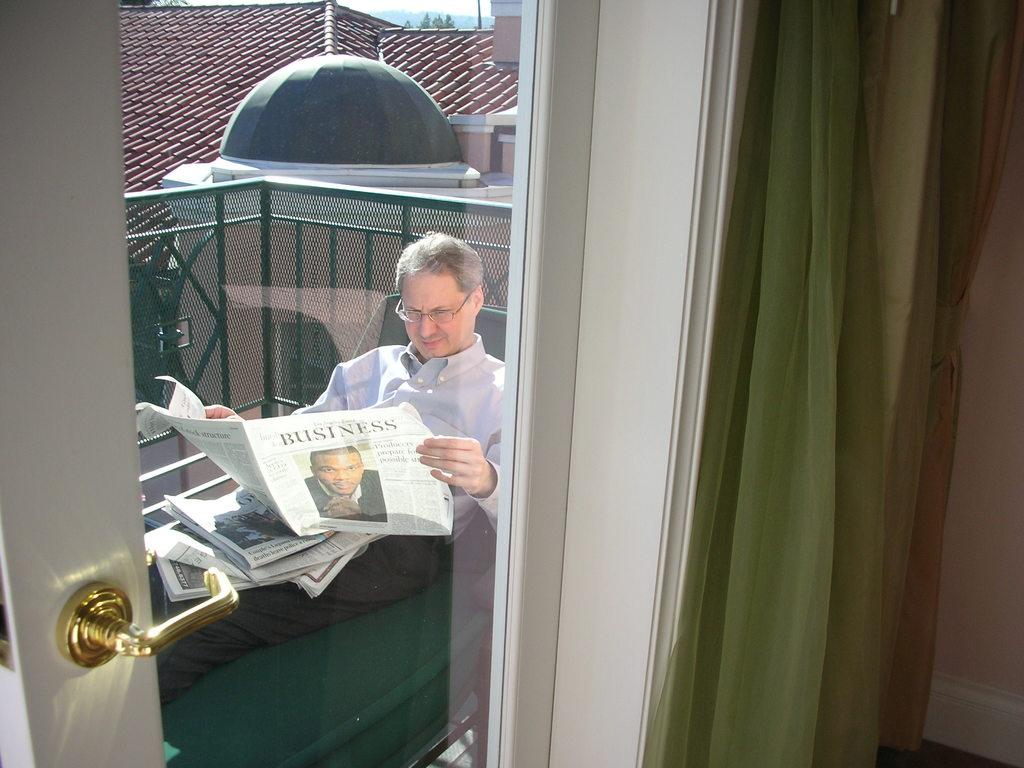What type of structures can be seen in the image? There are houses in the image. What type of window treatment is present in the image? There is a curtain in the image. What type of barrier can be seen in the image? There is a fence in the image. What type of reading material is present in the image? There are newspapers in the image. What type of entrance is present in the image? There is a door in the image. What is the person in the image doing? There is a person sitting in the image. What type of rice is being cooked in the image? There is no rice present in the image. What type of cannon is visible in the image? There is no cannon present in the image. What type of love is being expressed in the image? There is no love being expressed in the image; it features houses, a curtain, a fence, newspapers, a door, and a person sitting. 